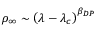<formula> <loc_0><loc_0><loc_500><loc_500>\rho _ { \infty } \sim \left ( \lambda - \lambda _ { c } \right ) ^ { \beta _ { D P } }</formula> 